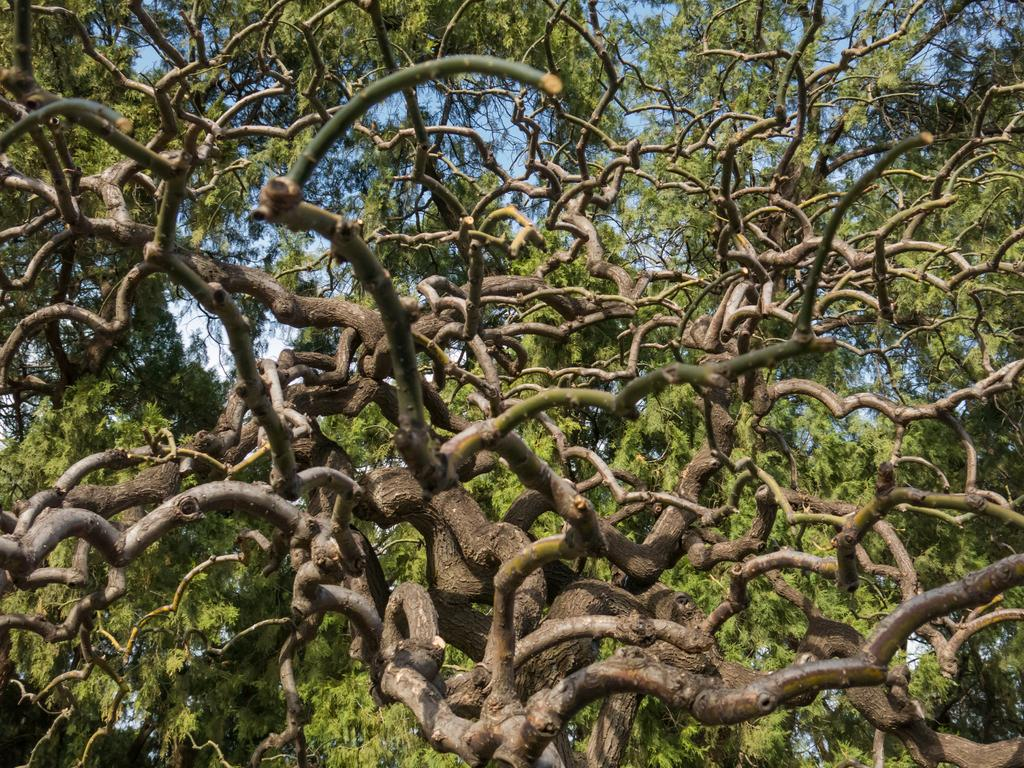What type of natural elements can be seen in the image? There are branches of trees present in the image. What type of game is being played on the branches of trees in the image? There is no game being played on the branches of trees in the image; they are simply branches of trees. 